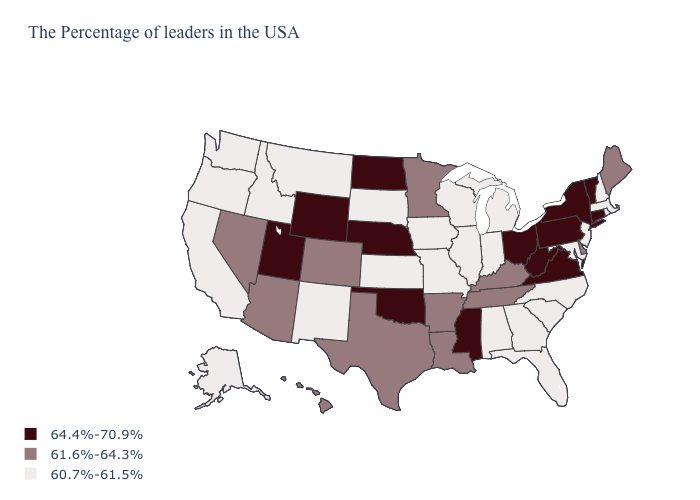Is the legend a continuous bar?
Answer briefly. No. Name the states that have a value in the range 60.7%-61.5%?
Keep it brief. Massachusetts, Rhode Island, New Hampshire, New Jersey, Maryland, North Carolina, South Carolina, Florida, Georgia, Michigan, Indiana, Alabama, Wisconsin, Illinois, Missouri, Iowa, Kansas, South Dakota, New Mexico, Montana, Idaho, California, Washington, Oregon, Alaska. What is the lowest value in the USA?
Answer briefly. 60.7%-61.5%. Name the states that have a value in the range 61.6%-64.3%?
Write a very short answer. Maine, Delaware, Kentucky, Tennessee, Louisiana, Arkansas, Minnesota, Texas, Colorado, Arizona, Nevada, Hawaii. What is the value of Florida?
Quick response, please. 60.7%-61.5%. Does New Jersey have the same value as Connecticut?
Give a very brief answer. No. Does Florida have the highest value in the South?
Quick response, please. No. What is the value of Utah?
Write a very short answer. 64.4%-70.9%. Does Iowa have the highest value in the MidWest?
Short answer required. No. Name the states that have a value in the range 64.4%-70.9%?
Quick response, please. Vermont, Connecticut, New York, Pennsylvania, Virginia, West Virginia, Ohio, Mississippi, Nebraska, Oklahoma, North Dakota, Wyoming, Utah. Name the states that have a value in the range 64.4%-70.9%?
Keep it brief. Vermont, Connecticut, New York, Pennsylvania, Virginia, West Virginia, Ohio, Mississippi, Nebraska, Oklahoma, North Dakota, Wyoming, Utah. What is the lowest value in states that border Ohio?
Be succinct. 60.7%-61.5%. What is the value of Mississippi?
Short answer required. 64.4%-70.9%. Name the states that have a value in the range 61.6%-64.3%?
Short answer required. Maine, Delaware, Kentucky, Tennessee, Louisiana, Arkansas, Minnesota, Texas, Colorado, Arizona, Nevada, Hawaii. Does West Virginia have the highest value in the USA?
Give a very brief answer. Yes. 